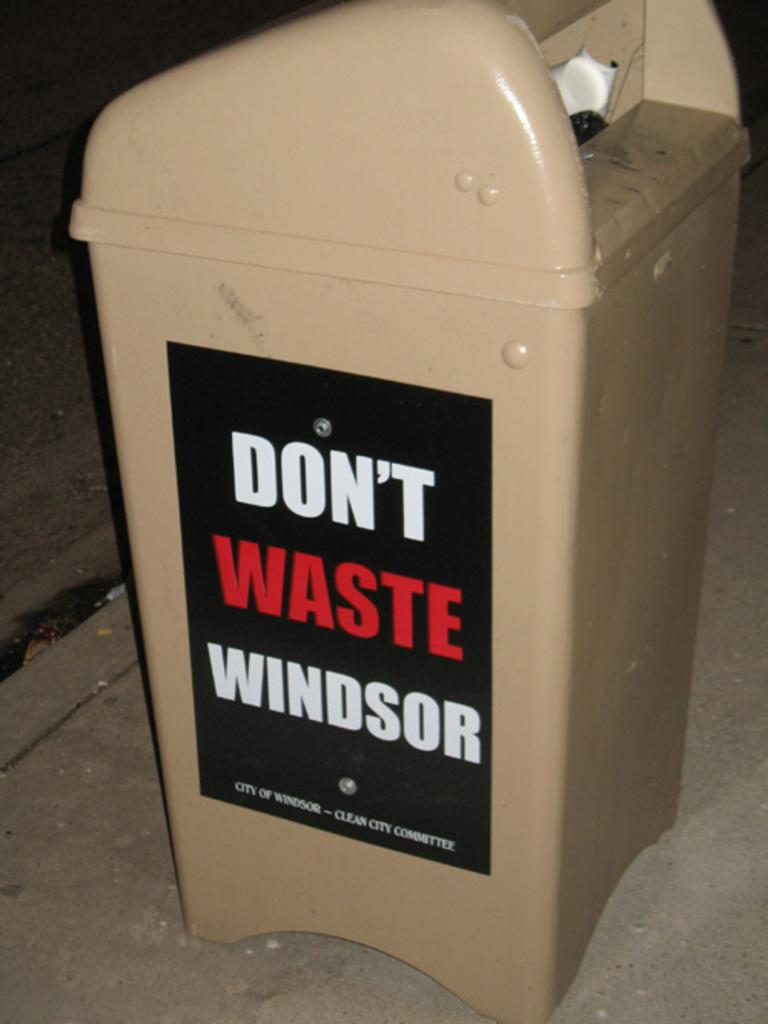<image>
Provide a brief description of the given image. A trash can by the city of Windsor with an add on the side. 